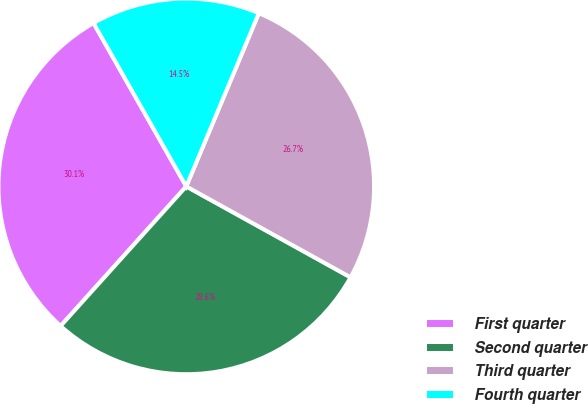Convert chart. <chart><loc_0><loc_0><loc_500><loc_500><pie_chart><fcel>First quarter<fcel>Second quarter<fcel>Third quarter<fcel>Fourth quarter<nl><fcel>30.12%<fcel>28.62%<fcel>26.73%<fcel>14.53%<nl></chart> 